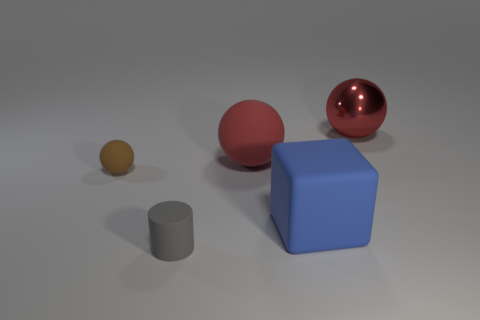The large object in front of the red rubber ball has what shape?
Your response must be concise. Cube. The matte object that is the same size as the gray cylinder is what shape?
Your answer should be very brief. Sphere. Is there a big object of the same shape as the small brown object?
Keep it short and to the point. Yes. Is the shape of the rubber object that is behind the small brown object the same as the tiny rubber thing behind the large blue matte thing?
Make the answer very short. Yes. There is another red sphere that is the same size as the red rubber sphere; what material is it?
Your answer should be compact. Metal. What number of other things are the same material as the cylinder?
Make the answer very short. 3. What is the shape of the matte thing behind the thing on the left side of the gray cylinder?
Provide a short and direct response. Sphere. How many things are big green cylinders or red balls that are in front of the red metallic sphere?
Offer a very short reply. 1. What number of other things are the same color as the metal object?
Make the answer very short. 1. How many purple things are balls or small cylinders?
Offer a terse response. 0. 